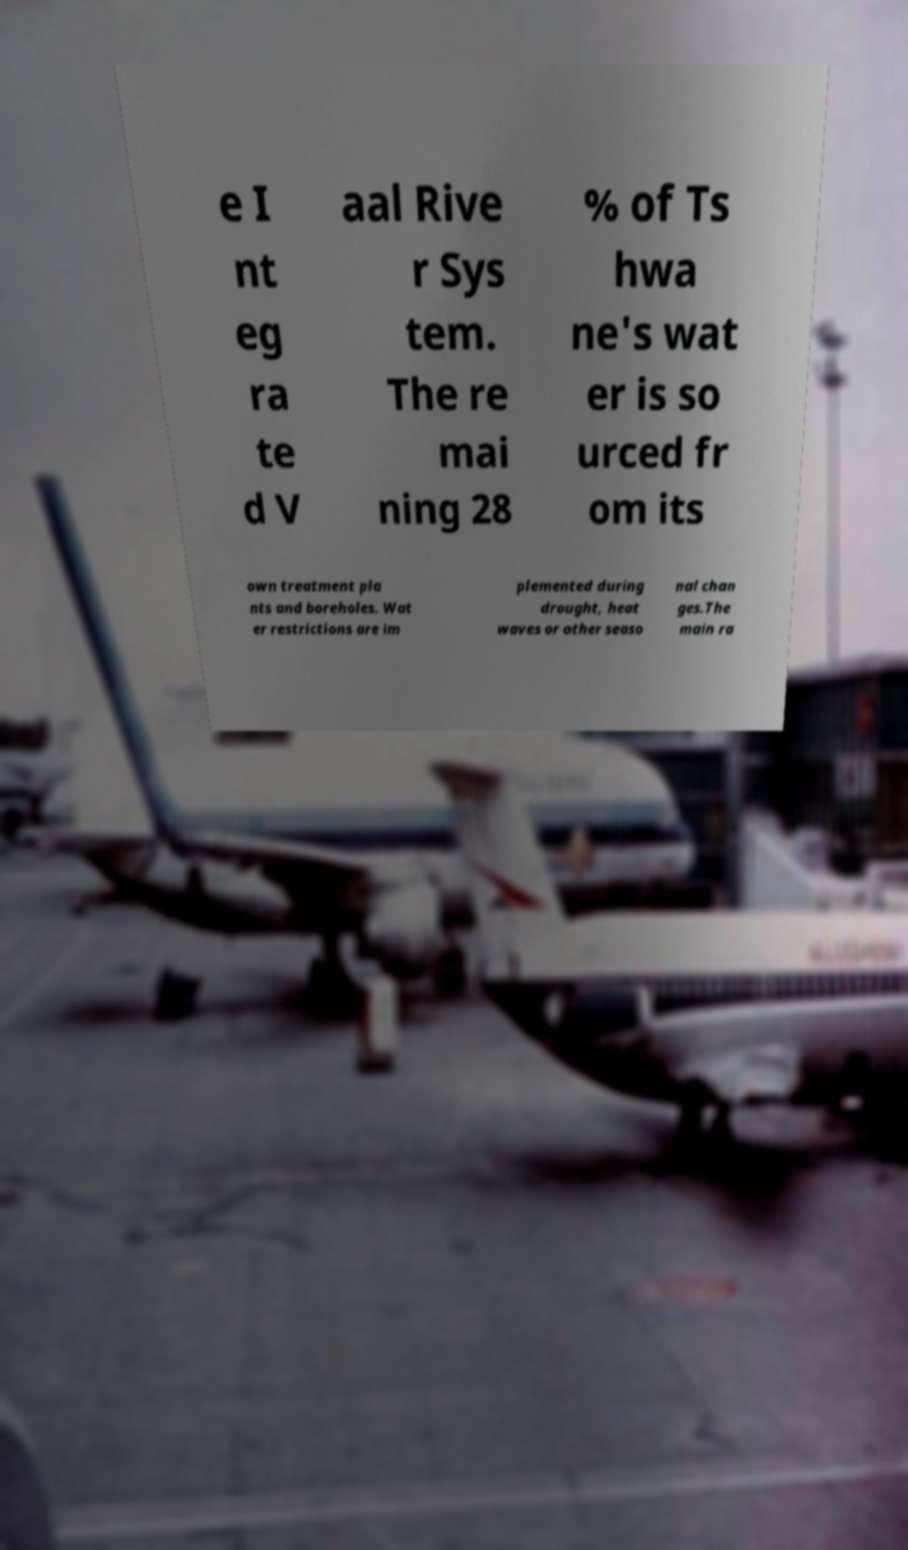Could you extract and type out the text from this image? e I nt eg ra te d V aal Rive r Sys tem. The re mai ning 28 % of Ts hwa ne's wat er is so urced fr om its own treatment pla nts and boreholes. Wat er restrictions are im plemented during drought, heat waves or other seaso nal chan ges.The main ra 